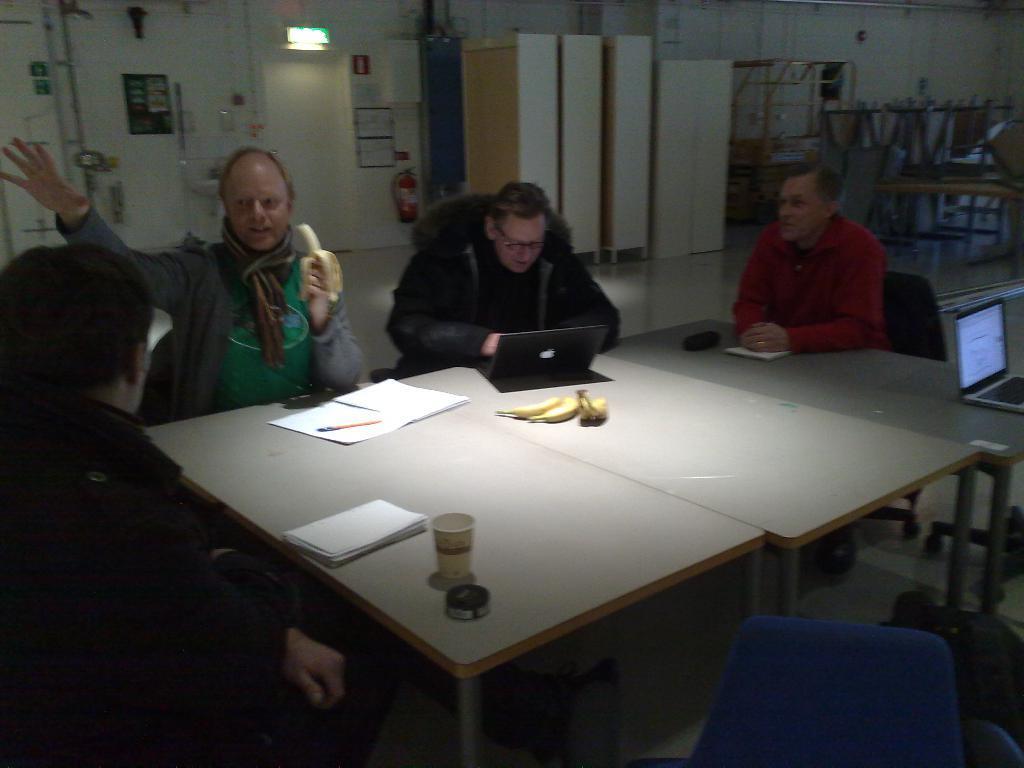How would you summarize this image in a sentence or two? In this image there are group of people who are sitting on a chair, in front of them there is one table and on that table there are some papers and bananas and laptop is there. On the background there are some racks, door, wall are there. 